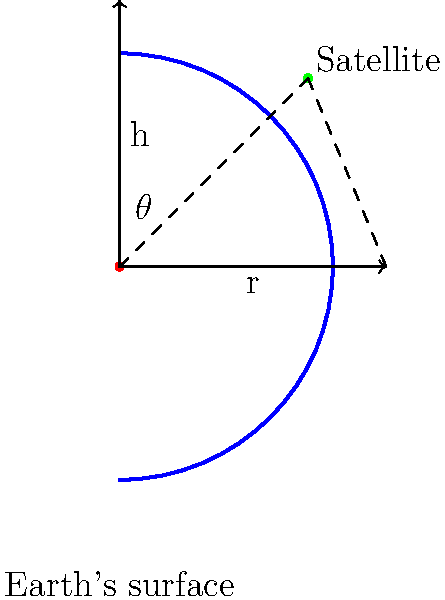During a major earthquake, GPS accuracy is crucial for coordinating emergency response. Given that the curvature of space-time affects GPS signals, calculate the angle $\theta$ between the straight-line path and the curved path of a GPS signal from a satellite to a receiver on Earth's surface. Assume the satellite is at an altitude of $h = 20,000$ km, Earth's radius is $r = 6,371$ km, and the signal follows a geodesic in curved space-time. To solve this problem, we need to consider the effects of general relativity on the path of the GPS signal. Here's a step-by-step approach:

1) In flat space-time, the angle $\theta$ would be zero, as the signal would travel in a straight line.

2) However, due to the curvature of space-time caused by Earth's mass, the signal follows a curved path (geodesic).

3) The amount of curvature can be approximated using the Schwarzschild metric, which describes the geometry of space-time around a spherical mass.

4) The angle of deflection $\theta$ is given by the equation:

   $$\theta \approx \frac{4GM}{c^2r}$$

   Where:
   - $G$ is the gravitational constant ($6.674 \times 10^{-11} \text{ m}^3 \text{ kg}^{-1} \text{ s}^{-2}$)
   - $M$ is the mass of Earth ($5.972 \times 10^{24} \text{ kg}$)
   - $c$ is the speed of light ($2.998 \times 10^8 \text{ m/s}$)
   - $r$ is the distance of closest approach (Earth's radius in this case)

5) Substituting the values:

   $$\theta \approx \frac{4 \times (6.674 \times 10^{-11}) \times (5.972 \times 10^{24})}{(2.998 \times 10^8)^2 \times (6.371 \times 10^6)}$$

6) Calculating:

   $$\theta \approx 8.49 \times 10^{-6} \text{ radians}$$

7) Converting to arcseconds:

   $$\theta \approx 1.75 \text{ arcseconds}$$

This small angle can cause significant positioning errors over large distances, potentially affecting emergency response coordination during disasters.
Answer: 1.75 arcseconds 